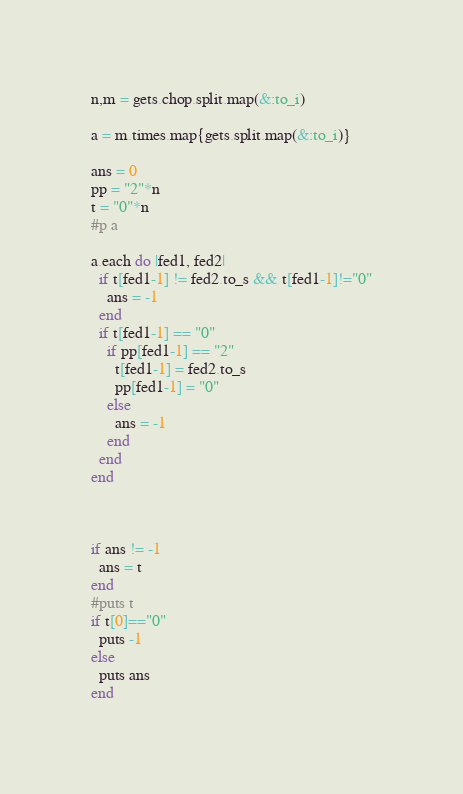Convert code to text. <code><loc_0><loc_0><loc_500><loc_500><_Ruby_>
n,m = gets.chop.split.map(&:to_i)

a = m.times.map{gets.split.map(&:to_i)}

ans = 0
pp = "2"*n
t = "0"*n
#p a

a.each do |fed1, fed2|
  if t[fed1-1] != fed2.to_s && t[fed1-1]!="0"
    ans = -1
  end
  if t[fed1-1] == "0"
    if pp[fed1-1] == "2"
      t[fed1-1] = fed2.to_s
      pp[fed1-1] = "0"
    else
      ans = -1
    end
  end
end



if ans != -1
  ans = t
end
#puts t
if t[0]=="0"
  puts -1
else
  puts ans
end</code> 